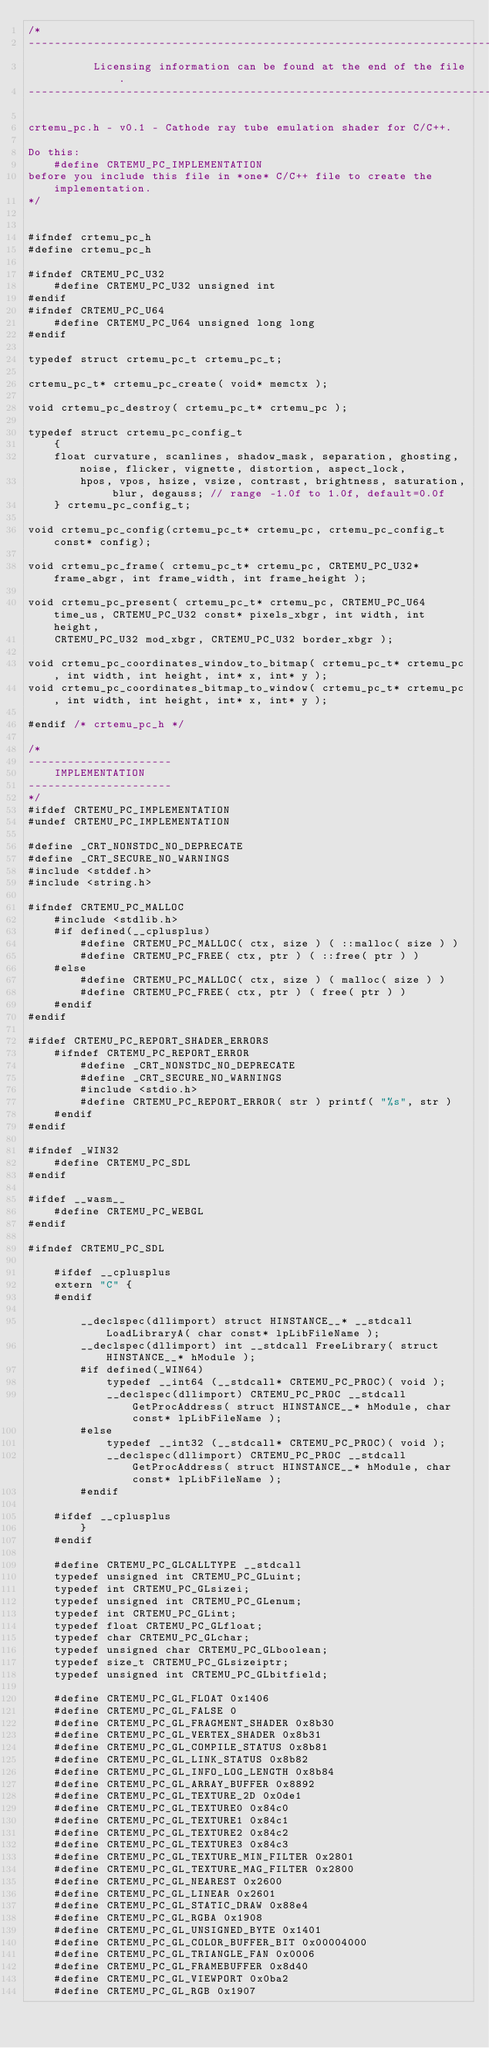Convert code to text. <code><loc_0><loc_0><loc_500><loc_500><_C_>/*
------------------------------------------------------------------------------
          Licensing information can be found at the end of the file.
------------------------------------------------------------------------------

crtemu_pc.h - v0.1 - Cathode ray tube emulation shader for C/C++.

Do this:
    #define CRTEMU_PC_IMPLEMENTATION
before you include this file in *one* C/C++ file to create the implementation.
*/


#ifndef crtemu_pc_h
#define crtemu_pc_h

#ifndef CRTEMU_PC_U32
    #define CRTEMU_PC_U32 unsigned int
#endif
#ifndef CRTEMU_PC_U64
    #define CRTEMU_PC_U64 unsigned long long
#endif

typedef struct crtemu_pc_t crtemu_pc_t;

crtemu_pc_t* crtemu_pc_create( void* memctx );

void crtemu_pc_destroy( crtemu_pc_t* crtemu_pc );

typedef struct crtemu_pc_config_t 
    { 
    float curvature, scanlines, shadow_mask, separation, ghosting, noise, flicker, vignette, distortion, aspect_lock,
        hpos, vpos, hsize, vsize, contrast, brightness, saturation, blur, degauss; // range -1.0f to 1.0f, default=0.0f
    } crtemu_pc_config_t;

void crtemu_pc_config(crtemu_pc_t* crtemu_pc, crtemu_pc_config_t const* config);

void crtemu_pc_frame( crtemu_pc_t* crtemu_pc, CRTEMU_PC_U32* frame_abgr, int frame_width, int frame_height );

void crtemu_pc_present( crtemu_pc_t* crtemu_pc, CRTEMU_PC_U64 time_us, CRTEMU_PC_U32 const* pixels_xbgr, int width, int height, 
    CRTEMU_PC_U32 mod_xbgr, CRTEMU_PC_U32 border_xbgr );

void crtemu_pc_coordinates_window_to_bitmap( crtemu_pc_t* crtemu_pc, int width, int height, int* x, int* y );
void crtemu_pc_coordinates_bitmap_to_window( crtemu_pc_t* crtemu_pc, int width, int height, int* x, int* y );

#endif /* crtemu_pc_h */

/*
----------------------
    IMPLEMENTATION
----------------------
*/
#ifdef CRTEMU_PC_IMPLEMENTATION
#undef CRTEMU_PC_IMPLEMENTATION

#define _CRT_NONSTDC_NO_DEPRECATE 
#define _CRT_SECURE_NO_WARNINGS
#include <stddef.h>
#include <string.h>

#ifndef CRTEMU_PC_MALLOC
    #include <stdlib.h>
    #if defined(__cplusplus)
        #define CRTEMU_PC_MALLOC( ctx, size ) ( ::malloc( size ) )
        #define CRTEMU_PC_FREE( ctx, ptr ) ( ::free( ptr ) )
    #else
        #define CRTEMU_PC_MALLOC( ctx, size ) ( malloc( size ) )
        #define CRTEMU_PC_FREE( ctx, ptr ) ( free( ptr ) )
    #endif
#endif

#ifdef CRTEMU_PC_REPORT_SHADER_ERRORS
    #ifndef CRTEMU_PC_REPORT_ERROR
        #define _CRT_NONSTDC_NO_DEPRECATE 
        #define _CRT_SECURE_NO_WARNINGS
        #include <stdio.h>
        #define CRTEMU_PC_REPORT_ERROR( str ) printf( "%s", str )
    #endif
#endif

#ifndef _WIN32 
    #define CRTEMU_PC_SDL
#endif

#ifdef __wasm__
    #define CRTEMU_PC_WEBGL
#endif

#ifndef CRTEMU_PC_SDL

    #ifdef __cplusplus
    extern "C" {
    #endif

        __declspec(dllimport) struct HINSTANCE__* __stdcall LoadLibraryA( char const* lpLibFileName );
        __declspec(dllimport) int __stdcall FreeLibrary( struct HINSTANCE__* hModule );
        #if defined(_WIN64)
            typedef __int64 (__stdcall* CRTEMU_PC_PROC)( void );
            __declspec(dllimport) CRTEMU_PC_PROC __stdcall GetProcAddress( struct HINSTANCE__* hModule, char const* lpLibFileName );
        #else
            typedef __int32 (__stdcall* CRTEMU_PC_PROC)( void );
            __declspec(dllimport) CRTEMU_PC_PROC __stdcall GetProcAddress( struct HINSTANCE__* hModule, char const* lpLibFileName );
        #endif

    #ifdef __cplusplus
        }
    #endif

    #define CRTEMU_PC_GLCALLTYPE __stdcall
    typedef unsigned int CRTEMU_PC_GLuint;
    typedef int CRTEMU_PC_GLsizei;
    typedef unsigned int CRTEMU_PC_GLenum;
    typedef int CRTEMU_PC_GLint;
    typedef float CRTEMU_PC_GLfloat;
    typedef char CRTEMU_PC_GLchar;
    typedef unsigned char CRTEMU_PC_GLboolean;
    typedef size_t CRTEMU_PC_GLsizeiptr;
    typedef unsigned int CRTEMU_PC_GLbitfield;

    #define CRTEMU_PC_GL_FLOAT 0x1406
    #define CRTEMU_PC_GL_FALSE 0
    #define CRTEMU_PC_GL_FRAGMENT_SHADER 0x8b30
    #define CRTEMU_PC_GL_VERTEX_SHADER 0x8b31
    #define CRTEMU_PC_GL_COMPILE_STATUS 0x8b81
    #define CRTEMU_PC_GL_LINK_STATUS 0x8b82
    #define CRTEMU_PC_GL_INFO_LOG_LENGTH 0x8b84
    #define CRTEMU_PC_GL_ARRAY_BUFFER 0x8892
    #define CRTEMU_PC_GL_TEXTURE_2D 0x0de1
    #define CRTEMU_PC_GL_TEXTURE0 0x84c0
    #define CRTEMU_PC_GL_TEXTURE1 0x84c1
    #define CRTEMU_PC_GL_TEXTURE2 0x84c2
    #define CRTEMU_PC_GL_TEXTURE3 0x84c3
    #define CRTEMU_PC_GL_TEXTURE_MIN_FILTER 0x2801
    #define CRTEMU_PC_GL_TEXTURE_MAG_FILTER 0x2800
    #define CRTEMU_PC_GL_NEAREST 0x2600
    #define CRTEMU_PC_GL_LINEAR 0x2601
    #define CRTEMU_PC_GL_STATIC_DRAW 0x88e4
    #define CRTEMU_PC_GL_RGBA 0x1908
    #define CRTEMU_PC_GL_UNSIGNED_BYTE 0x1401
    #define CRTEMU_PC_GL_COLOR_BUFFER_BIT 0x00004000
    #define CRTEMU_PC_GL_TRIANGLE_FAN 0x0006
    #define CRTEMU_PC_GL_FRAMEBUFFER 0x8d40
    #define CRTEMU_PC_GL_VIEWPORT 0x0ba2
    #define CRTEMU_PC_GL_RGB 0x1907</code> 